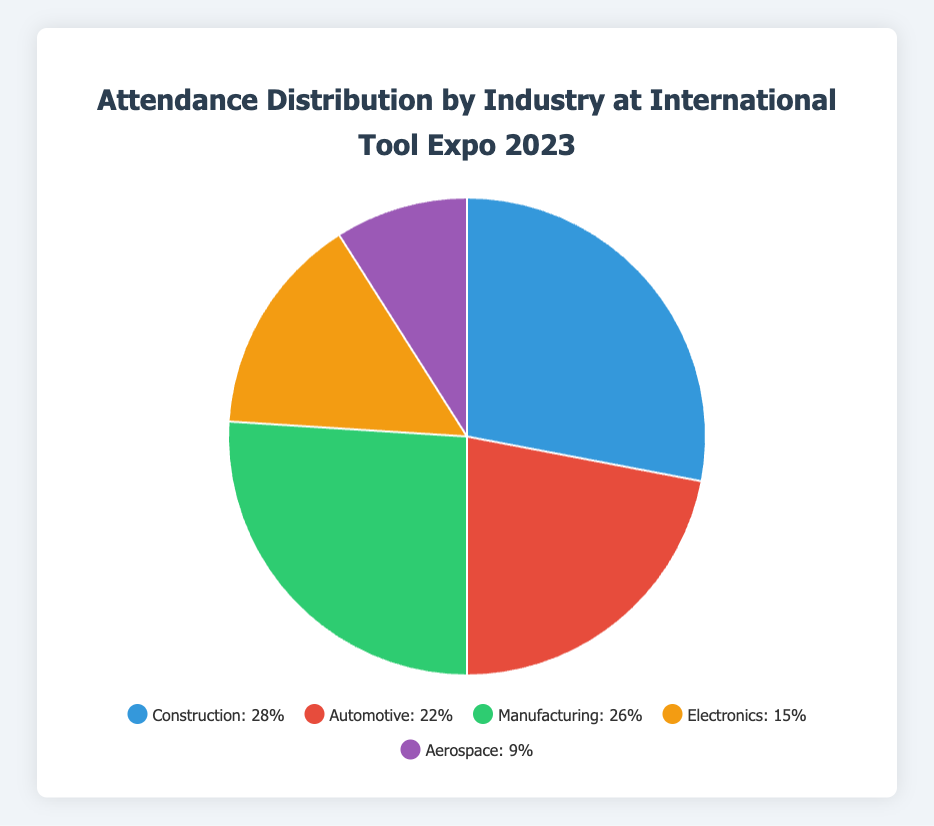Which industry had the highest attendance percentage at the International Tool Expo 2023? The industry with the highest percentage can be found by identifying the largest sector in the pie chart, which is Construction at 28%.
Answer: Construction Which two industries combined account for more than half of the total attendance? Adding the percentages for the two largest industries, Construction (28%) and Manufacturing (26%), gives 28% + 26% = 54%, which is more than half.
Answer: Construction and Manufacturing Which industry had the lowest representation at the trade show, and what percentage did it constitute? Looking at the smallest sector in the pie chart, Aerospace had the lowest percentage of attendance at 9%.
Answer: Aerospace, 9% How does the attendance for the Automotive industry compare to the Electronics industry? Comparing the two industries, Automotive (22%) has a higher attendance percentage than Electronics (15%).
Answer: Automotive attendance is higher than Electronics What is the combined percentage of attendees from the Automotive and Aerospace industries? Add the percentages for Automotive (22%) and Aerospace (9%) which equals 22% + 9% = 31%.
Answer: 31% By how much does the attendance percentage for Manufacturing exceed that of Aerospace? Subtract the percentage of Aerospace (9%) from Manufacturing (26%) which equals 26% - 9% = 17%.
Answer: 17% What is the difference in attendance between the industry with the highest and the industry with the lowest attendance percentages? Subtract the percentage of the industry with the lowest attendance (Aerospace, 9%) from the highest (Construction, 28%) which equals 28% - 9% = 19%.
Answer: 19% Which color on the pie chart represents the Electronics industry? Identifying from the pie chart, the Electronics industry is represented by an orange color.
Answer: Orange What percentage of the attendees belong to either the Manufacturing or Electronics industries? Adding the percentages for Manufacturing (26%) and Electronics (15%) gives 26% + 15% = 41%.
Answer: 41% If the total number of attendees was 1,000, how many attendees were from the Construction industry? Multiply the total number of attendees by the percentage of Construction attendees: 1000 * 0.28 = 280.
Answer: 280 attendees 